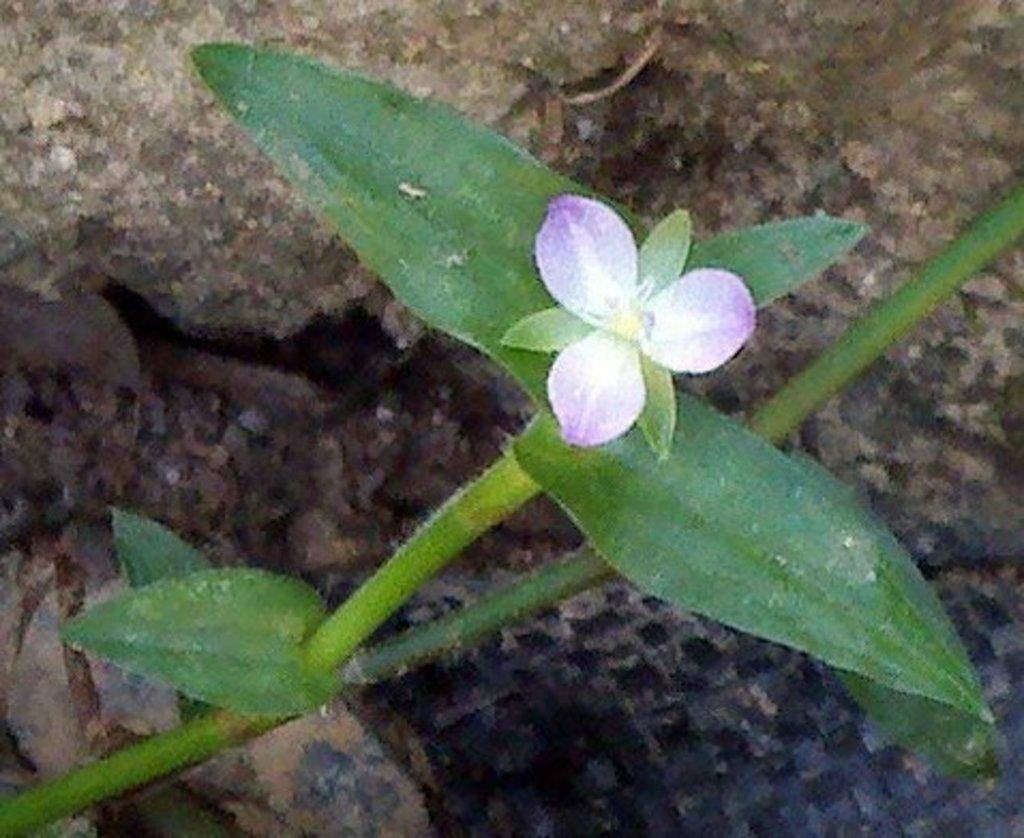What type of plant is in the image? There is a small plant in the image. What features can be observed on the plant? The plant has a flower and leaves. What type of glue is used to attach the flower to the plant in the image? There is no glue present in the image; the flower is naturally attached to the plant. Can you tell me what the plant is saying to the writer in the image? There is no writer or talking in the image; it only features a small plant with a flower and leaves. 